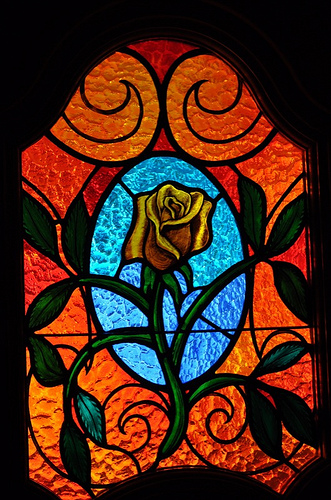<image>
Can you confirm if the rose is in front of the window? No. The rose is not in front of the window. The spatial positioning shows a different relationship between these objects. 